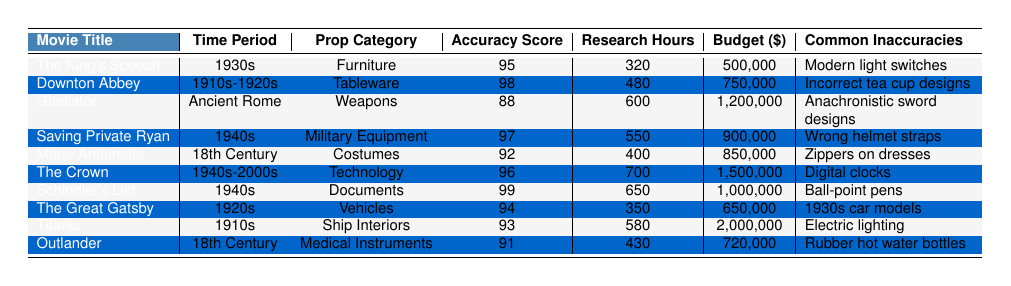What is the accuracy score of "Schindler's List"? The accuracy score for "Schindler's List" is directly listed in the table next to the movie title, and it shows a score of 99.
Answer: 99 Which prop category received the highest accuracy score? The table reveals the accuracy scores for each prop category. "Documents" from "Schindler's List" has the highest accuracy score of 99.
Answer: Documents How many research hours were dedicated to "The Crown"? The research hours for "The Crown" are displayed in the table, indicating a total of 700 hours allocated for research.
Answer: 700 What is the average accuracy score of all the movies listed? To find the average, sum all the accuracy scores (95 + 98 + 88 + 97 + 92 + 96 + 99 + 94 + 93 + 91 =  949) and divide by the number of movies (10), leading to 949 / 10 = 94.9.
Answer: 94.9 Which movie had the least budget allocated for props? By comparing the budget figures in the table, "The Great Gatsby" shows a budget of 650,000, which is the smallest amount among the listed movies.
Answer: The Great Gatsby Is it true that all movies set in the 18th Century have a prop authenticity rating above 4.5? The authenticity ratings for "Marie Antoinette" and "Outlander" were checked, showing ratings of 4.7 and 4.6 respectively, which confirms that both movies meet the criteria.
Answer: Yes What is the difference in budget allocation between "Titanic" and "Outlander"? The budget for "Titanic" is 2,000,000 and for "Outlander" is 720,000. The difference is calculated as 2,000,000 - 720,000 = 1,280,000.
Answer: 1,280,000 How many specialized craftsmen were involved in the production of "Gladiator"? The table specifies that 25 specialized craftsmen were involved in the production of "Gladiator."
Answer: 25 What is the prop category with the maximum number of research hours? By reviewing the research hours in the table, "The Crown" had the most research hours allocated (700), which indicates it also had a high level of detail in its prop design.
Answer: Technology Which movie has a common inaccuracy related to modern technology? The table shows "The Crown" with the common inaccuracy of digital clocks, indicating its failure to accurately depict the period's technology.
Answer: The Crown 